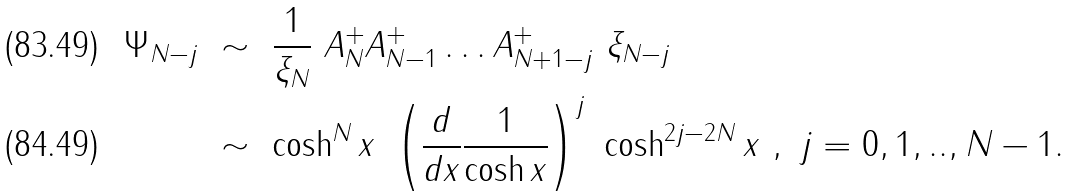Convert formula to latex. <formula><loc_0><loc_0><loc_500><loc_500>\Psi _ { N - j } \ & \sim \ \frac { 1 } { \xi _ { N } } \ A _ { N } ^ { + } A _ { N - 1 } ^ { + } \dots A _ { N + 1 - j } ^ { + } \ \xi _ { N - j } \\ \ & \sim \ \cosh ^ { N } x \ \left ( \frac { d } { d x } \frac { 1 } { \cosh x } \right ) ^ { j } \ \cosh ^ { 2 j - 2 N } x \ , \ j = 0 , 1 , . . , N - 1 .</formula> 